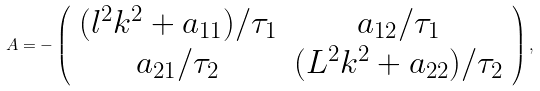Convert formula to latex. <formula><loc_0><loc_0><loc_500><loc_500>A = - \left ( \begin{array} { c c } ( l ^ { 2 } k ^ { 2 } + a _ { 1 1 } ) / \tau _ { 1 } & a _ { 1 2 } / \tau _ { 1 } \\ a _ { 2 1 } / \tau _ { 2 } & ( L ^ { 2 } k ^ { 2 } + a _ { 2 2 } ) / \tau _ { 2 } \end{array} \right ) ,</formula> 